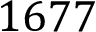<formula> <loc_0><loc_0><loc_500><loc_500>1 6 7 7</formula> 